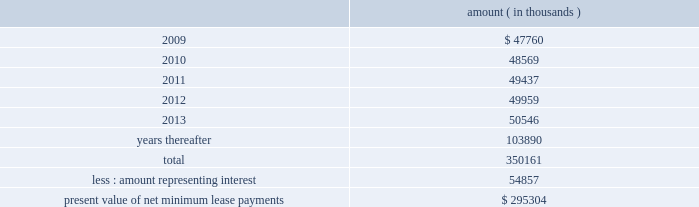Entergy corporation and subsidiaries notes to financial statements as of december 31 , 2008 , system energy had future minimum lease payments ( reflecting an implicit rate of 5.13% ( 5.13 % ) ) , which are recorded as long-term debt as follows : amount ( in thousands ) .

What percent lower is the net present than the total payments value of lease payments? 
Computations: (350161 / 295304)
Answer: 1.18576. Entergy corporation and subsidiaries notes to financial statements as of december 31 , 2008 , system energy had future minimum lease payments ( reflecting an implicit rate of 5.13% ( 5.13 % ) ) , which are recorded as long-term debt as follows : amount ( in thousands ) .

What portion of the total lease payments is due in the next 12 months? 
Computations: (47760 / 350161)
Answer: 0.13639. Entergy corporation and subsidiaries notes to financial statements as of december 31 , 2008 , system energy had future minimum lease payments ( reflecting an implicit rate of 5.13% ( 5.13 % ) ) , which are recorded as long-term debt as follows : amount ( in thousands ) .

What portion of the total minimum lease payments is related to interest? 
Computations: (54857 / 350161)
Answer: 0.15666. 